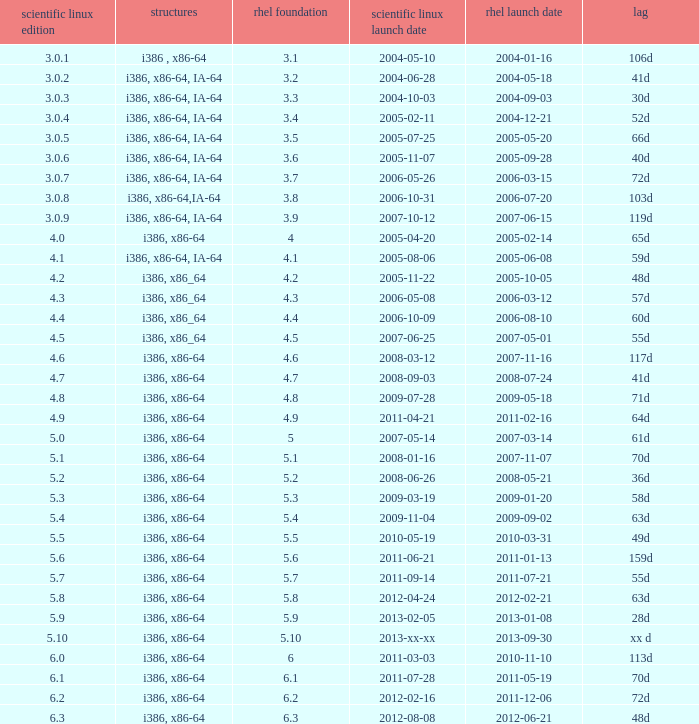Name the scientific linux release when delay is 28d 5.9. 